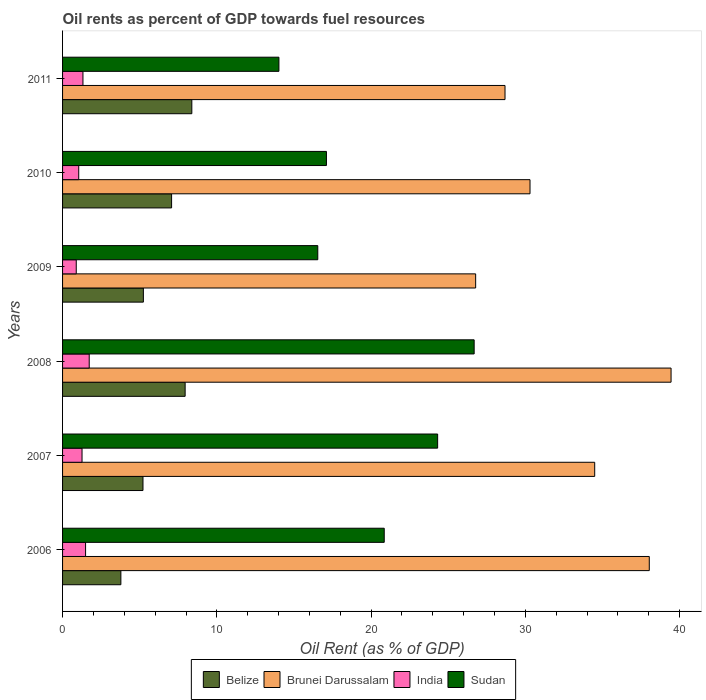How many different coloured bars are there?
Keep it short and to the point. 4. How many groups of bars are there?
Your answer should be very brief. 6. Are the number of bars per tick equal to the number of legend labels?
Offer a very short reply. Yes. How many bars are there on the 3rd tick from the top?
Your answer should be very brief. 4. What is the label of the 1st group of bars from the top?
Give a very brief answer. 2011. What is the oil rent in Brunei Darussalam in 2009?
Your answer should be very brief. 26.77. Across all years, what is the maximum oil rent in Brunei Darussalam?
Offer a terse response. 39.44. Across all years, what is the minimum oil rent in Sudan?
Ensure brevity in your answer.  14.02. What is the total oil rent in Belize in the graph?
Ensure brevity in your answer.  37.62. What is the difference between the oil rent in Sudan in 2008 and that in 2011?
Your answer should be compact. 12.65. What is the difference between the oil rent in India in 2010 and the oil rent in Brunei Darussalam in 2007?
Your response must be concise. -33.44. What is the average oil rent in Sudan per year?
Offer a terse response. 19.92. In the year 2006, what is the difference between the oil rent in Sudan and oil rent in Brunei Darussalam?
Offer a terse response. -17.18. What is the ratio of the oil rent in Sudan in 2006 to that in 2010?
Provide a succinct answer. 1.22. Is the oil rent in Sudan in 2006 less than that in 2010?
Ensure brevity in your answer.  No. What is the difference between the highest and the second highest oil rent in India?
Provide a succinct answer. 0.24. What is the difference between the highest and the lowest oil rent in Belize?
Your answer should be very brief. 4.6. Is the sum of the oil rent in Brunei Darussalam in 2007 and 2008 greater than the maximum oil rent in Belize across all years?
Your answer should be very brief. Yes. What does the 3rd bar from the top in 2009 represents?
Offer a terse response. Brunei Darussalam. What does the 4th bar from the bottom in 2008 represents?
Offer a very short reply. Sudan. How many bars are there?
Keep it short and to the point. 24. How many years are there in the graph?
Provide a short and direct response. 6. What is the difference between two consecutive major ticks on the X-axis?
Provide a succinct answer. 10. Does the graph contain grids?
Your answer should be compact. No. Where does the legend appear in the graph?
Your answer should be very brief. Bottom center. How many legend labels are there?
Your answer should be very brief. 4. How are the legend labels stacked?
Provide a succinct answer. Horizontal. What is the title of the graph?
Your answer should be very brief. Oil rents as percent of GDP towards fuel resources. Does "High income: nonOECD" appear as one of the legend labels in the graph?
Your response must be concise. No. What is the label or title of the X-axis?
Make the answer very short. Oil Rent (as % of GDP). What is the label or title of the Y-axis?
Offer a very short reply. Years. What is the Oil Rent (as % of GDP) in Belize in 2006?
Keep it short and to the point. 3.78. What is the Oil Rent (as % of GDP) of Brunei Darussalam in 2006?
Ensure brevity in your answer.  38.03. What is the Oil Rent (as % of GDP) in India in 2006?
Make the answer very short. 1.49. What is the Oil Rent (as % of GDP) of Sudan in 2006?
Offer a very short reply. 20.85. What is the Oil Rent (as % of GDP) of Belize in 2007?
Your answer should be compact. 5.21. What is the Oil Rent (as % of GDP) of Brunei Darussalam in 2007?
Provide a short and direct response. 34.49. What is the Oil Rent (as % of GDP) of India in 2007?
Keep it short and to the point. 1.26. What is the Oil Rent (as % of GDP) in Sudan in 2007?
Make the answer very short. 24.31. What is the Oil Rent (as % of GDP) in Belize in 2008?
Your answer should be compact. 7.94. What is the Oil Rent (as % of GDP) in Brunei Darussalam in 2008?
Your response must be concise. 39.44. What is the Oil Rent (as % of GDP) in India in 2008?
Your answer should be compact. 1.73. What is the Oil Rent (as % of GDP) of Sudan in 2008?
Keep it short and to the point. 26.68. What is the Oil Rent (as % of GDP) in Belize in 2009?
Provide a short and direct response. 5.24. What is the Oil Rent (as % of GDP) of Brunei Darussalam in 2009?
Provide a short and direct response. 26.77. What is the Oil Rent (as % of GDP) of India in 2009?
Give a very brief answer. 0.89. What is the Oil Rent (as % of GDP) in Sudan in 2009?
Provide a succinct answer. 16.54. What is the Oil Rent (as % of GDP) in Belize in 2010?
Ensure brevity in your answer.  7.07. What is the Oil Rent (as % of GDP) in Brunei Darussalam in 2010?
Keep it short and to the point. 30.3. What is the Oil Rent (as % of GDP) of India in 2010?
Your response must be concise. 1.05. What is the Oil Rent (as % of GDP) of Sudan in 2010?
Make the answer very short. 17.1. What is the Oil Rent (as % of GDP) of Belize in 2011?
Keep it short and to the point. 8.38. What is the Oil Rent (as % of GDP) of Brunei Darussalam in 2011?
Your answer should be compact. 28.68. What is the Oil Rent (as % of GDP) in India in 2011?
Your answer should be compact. 1.32. What is the Oil Rent (as % of GDP) in Sudan in 2011?
Provide a short and direct response. 14.02. Across all years, what is the maximum Oil Rent (as % of GDP) of Belize?
Provide a succinct answer. 8.38. Across all years, what is the maximum Oil Rent (as % of GDP) of Brunei Darussalam?
Your answer should be compact. 39.44. Across all years, what is the maximum Oil Rent (as % of GDP) in India?
Your answer should be compact. 1.73. Across all years, what is the maximum Oil Rent (as % of GDP) of Sudan?
Offer a terse response. 26.68. Across all years, what is the minimum Oil Rent (as % of GDP) of Belize?
Offer a terse response. 3.78. Across all years, what is the minimum Oil Rent (as % of GDP) of Brunei Darussalam?
Make the answer very short. 26.77. Across all years, what is the minimum Oil Rent (as % of GDP) in India?
Provide a succinct answer. 0.89. Across all years, what is the minimum Oil Rent (as % of GDP) in Sudan?
Offer a very short reply. 14.02. What is the total Oil Rent (as % of GDP) in Belize in the graph?
Ensure brevity in your answer.  37.62. What is the total Oil Rent (as % of GDP) in Brunei Darussalam in the graph?
Provide a succinct answer. 197.71. What is the total Oil Rent (as % of GDP) of India in the graph?
Offer a very short reply. 7.74. What is the total Oil Rent (as % of GDP) of Sudan in the graph?
Offer a very short reply. 119.51. What is the difference between the Oil Rent (as % of GDP) of Belize in 2006 and that in 2007?
Give a very brief answer. -1.43. What is the difference between the Oil Rent (as % of GDP) in Brunei Darussalam in 2006 and that in 2007?
Your answer should be compact. 3.54. What is the difference between the Oil Rent (as % of GDP) in India in 2006 and that in 2007?
Give a very brief answer. 0.23. What is the difference between the Oil Rent (as % of GDP) of Sudan in 2006 and that in 2007?
Ensure brevity in your answer.  -3.46. What is the difference between the Oil Rent (as % of GDP) in Belize in 2006 and that in 2008?
Provide a short and direct response. -4.17. What is the difference between the Oil Rent (as % of GDP) of Brunei Darussalam in 2006 and that in 2008?
Your answer should be compact. -1.41. What is the difference between the Oil Rent (as % of GDP) of India in 2006 and that in 2008?
Offer a terse response. -0.24. What is the difference between the Oil Rent (as % of GDP) of Sudan in 2006 and that in 2008?
Offer a very short reply. -5.83. What is the difference between the Oil Rent (as % of GDP) in Belize in 2006 and that in 2009?
Keep it short and to the point. -1.46. What is the difference between the Oil Rent (as % of GDP) of Brunei Darussalam in 2006 and that in 2009?
Your response must be concise. 11.25. What is the difference between the Oil Rent (as % of GDP) in India in 2006 and that in 2009?
Provide a succinct answer. 0.6. What is the difference between the Oil Rent (as % of GDP) in Sudan in 2006 and that in 2009?
Provide a succinct answer. 4.31. What is the difference between the Oil Rent (as % of GDP) in Belize in 2006 and that in 2010?
Keep it short and to the point. -3.29. What is the difference between the Oil Rent (as % of GDP) of Brunei Darussalam in 2006 and that in 2010?
Give a very brief answer. 7.73. What is the difference between the Oil Rent (as % of GDP) in India in 2006 and that in 2010?
Offer a very short reply. 0.44. What is the difference between the Oil Rent (as % of GDP) of Sudan in 2006 and that in 2010?
Make the answer very short. 3.75. What is the difference between the Oil Rent (as % of GDP) of Belize in 2006 and that in 2011?
Keep it short and to the point. -4.6. What is the difference between the Oil Rent (as % of GDP) in Brunei Darussalam in 2006 and that in 2011?
Keep it short and to the point. 9.35. What is the difference between the Oil Rent (as % of GDP) of India in 2006 and that in 2011?
Provide a short and direct response. 0.17. What is the difference between the Oil Rent (as % of GDP) in Sudan in 2006 and that in 2011?
Provide a succinct answer. 6.83. What is the difference between the Oil Rent (as % of GDP) of Belize in 2007 and that in 2008?
Provide a short and direct response. -2.73. What is the difference between the Oil Rent (as % of GDP) of Brunei Darussalam in 2007 and that in 2008?
Offer a very short reply. -4.95. What is the difference between the Oil Rent (as % of GDP) in India in 2007 and that in 2008?
Your response must be concise. -0.47. What is the difference between the Oil Rent (as % of GDP) of Sudan in 2007 and that in 2008?
Your answer should be very brief. -2.37. What is the difference between the Oil Rent (as % of GDP) in Belize in 2007 and that in 2009?
Provide a short and direct response. -0.03. What is the difference between the Oil Rent (as % of GDP) of Brunei Darussalam in 2007 and that in 2009?
Provide a short and direct response. 7.72. What is the difference between the Oil Rent (as % of GDP) of India in 2007 and that in 2009?
Keep it short and to the point. 0.38. What is the difference between the Oil Rent (as % of GDP) in Sudan in 2007 and that in 2009?
Provide a succinct answer. 7.77. What is the difference between the Oil Rent (as % of GDP) of Belize in 2007 and that in 2010?
Your answer should be compact. -1.85. What is the difference between the Oil Rent (as % of GDP) of Brunei Darussalam in 2007 and that in 2010?
Give a very brief answer. 4.19. What is the difference between the Oil Rent (as % of GDP) of India in 2007 and that in 2010?
Your response must be concise. 0.21. What is the difference between the Oil Rent (as % of GDP) of Sudan in 2007 and that in 2010?
Make the answer very short. 7.21. What is the difference between the Oil Rent (as % of GDP) of Belize in 2007 and that in 2011?
Offer a terse response. -3.17. What is the difference between the Oil Rent (as % of GDP) in Brunei Darussalam in 2007 and that in 2011?
Your response must be concise. 5.81. What is the difference between the Oil Rent (as % of GDP) of India in 2007 and that in 2011?
Offer a very short reply. -0.06. What is the difference between the Oil Rent (as % of GDP) in Sudan in 2007 and that in 2011?
Your answer should be very brief. 10.29. What is the difference between the Oil Rent (as % of GDP) in Belize in 2008 and that in 2009?
Ensure brevity in your answer.  2.71. What is the difference between the Oil Rent (as % of GDP) in Brunei Darussalam in 2008 and that in 2009?
Provide a short and direct response. 12.67. What is the difference between the Oil Rent (as % of GDP) of India in 2008 and that in 2009?
Offer a very short reply. 0.84. What is the difference between the Oil Rent (as % of GDP) of Sudan in 2008 and that in 2009?
Your answer should be very brief. 10.14. What is the difference between the Oil Rent (as % of GDP) in Belize in 2008 and that in 2010?
Ensure brevity in your answer.  0.88. What is the difference between the Oil Rent (as % of GDP) of Brunei Darussalam in 2008 and that in 2010?
Provide a succinct answer. 9.14. What is the difference between the Oil Rent (as % of GDP) in India in 2008 and that in 2010?
Keep it short and to the point. 0.68. What is the difference between the Oil Rent (as % of GDP) in Sudan in 2008 and that in 2010?
Provide a succinct answer. 9.57. What is the difference between the Oil Rent (as % of GDP) of Belize in 2008 and that in 2011?
Ensure brevity in your answer.  -0.43. What is the difference between the Oil Rent (as % of GDP) of Brunei Darussalam in 2008 and that in 2011?
Offer a very short reply. 10.76. What is the difference between the Oil Rent (as % of GDP) in India in 2008 and that in 2011?
Offer a terse response. 0.41. What is the difference between the Oil Rent (as % of GDP) of Sudan in 2008 and that in 2011?
Give a very brief answer. 12.65. What is the difference between the Oil Rent (as % of GDP) in Belize in 2009 and that in 2010?
Your response must be concise. -1.83. What is the difference between the Oil Rent (as % of GDP) in Brunei Darussalam in 2009 and that in 2010?
Your answer should be compact. -3.52. What is the difference between the Oil Rent (as % of GDP) in India in 2009 and that in 2010?
Offer a terse response. -0.16. What is the difference between the Oil Rent (as % of GDP) in Sudan in 2009 and that in 2010?
Give a very brief answer. -0.56. What is the difference between the Oil Rent (as % of GDP) of Belize in 2009 and that in 2011?
Your response must be concise. -3.14. What is the difference between the Oil Rent (as % of GDP) of Brunei Darussalam in 2009 and that in 2011?
Provide a short and direct response. -1.9. What is the difference between the Oil Rent (as % of GDP) of India in 2009 and that in 2011?
Ensure brevity in your answer.  -0.44. What is the difference between the Oil Rent (as % of GDP) in Sudan in 2009 and that in 2011?
Keep it short and to the point. 2.52. What is the difference between the Oil Rent (as % of GDP) in Belize in 2010 and that in 2011?
Offer a terse response. -1.31. What is the difference between the Oil Rent (as % of GDP) in Brunei Darussalam in 2010 and that in 2011?
Keep it short and to the point. 1.62. What is the difference between the Oil Rent (as % of GDP) of India in 2010 and that in 2011?
Make the answer very short. -0.27. What is the difference between the Oil Rent (as % of GDP) of Sudan in 2010 and that in 2011?
Your answer should be very brief. 3.08. What is the difference between the Oil Rent (as % of GDP) of Belize in 2006 and the Oil Rent (as % of GDP) of Brunei Darussalam in 2007?
Your response must be concise. -30.71. What is the difference between the Oil Rent (as % of GDP) in Belize in 2006 and the Oil Rent (as % of GDP) in India in 2007?
Your answer should be very brief. 2.52. What is the difference between the Oil Rent (as % of GDP) in Belize in 2006 and the Oil Rent (as % of GDP) in Sudan in 2007?
Your answer should be compact. -20.53. What is the difference between the Oil Rent (as % of GDP) of Brunei Darussalam in 2006 and the Oil Rent (as % of GDP) of India in 2007?
Make the answer very short. 36.77. What is the difference between the Oil Rent (as % of GDP) in Brunei Darussalam in 2006 and the Oil Rent (as % of GDP) in Sudan in 2007?
Your answer should be compact. 13.72. What is the difference between the Oil Rent (as % of GDP) of India in 2006 and the Oil Rent (as % of GDP) of Sudan in 2007?
Your answer should be compact. -22.82. What is the difference between the Oil Rent (as % of GDP) of Belize in 2006 and the Oil Rent (as % of GDP) of Brunei Darussalam in 2008?
Give a very brief answer. -35.66. What is the difference between the Oil Rent (as % of GDP) of Belize in 2006 and the Oil Rent (as % of GDP) of India in 2008?
Provide a succinct answer. 2.05. What is the difference between the Oil Rent (as % of GDP) of Belize in 2006 and the Oil Rent (as % of GDP) of Sudan in 2008?
Ensure brevity in your answer.  -22.9. What is the difference between the Oil Rent (as % of GDP) of Brunei Darussalam in 2006 and the Oil Rent (as % of GDP) of India in 2008?
Give a very brief answer. 36.3. What is the difference between the Oil Rent (as % of GDP) of Brunei Darussalam in 2006 and the Oil Rent (as % of GDP) of Sudan in 2008?
Your answer should be compact. 11.35. What is the difference between the Oil Rent (as % of GDP) of India in 2006 and the Oil Rent (as % of GDP) of Sudan in 2008?
Keep it short and to the point. -25.19. What is the difference between the Oil Rent (as % of GDP) of Belize in 2006 and the Oil Rent (as % of GDP) of Brunei Darussalam in 2009?
Offer a terse response. -23. What is the difference between the Oil Rent (as % of GDP) of Belize in 2006 and the Oil Rent (as % of GDP) of India in 2009?
Make the answer very short. 2.89. What is the difference between the Oil Rent (as % of GDP) of Belize in 2006 and the Oil Rent (as % of GDP) of Sudan in 2009?
Give a very brief answer. -12.76. What is the difference between the Oil Rent (as % of GDP) of Brunei Darussalam in 2006 and the Oil Rent (as % of GDP) of India in 2009?
Keep it short and to the point. 37.14. What is the difference between the Oil Rent (as % of GDP) of Brunei Darussalam in 2006 and the Oil Rent (as % of GDP) of Sudan in 2009?
Offer a terse response. 21.49. What is the difference between the Oil Rent (as % of GDP) of India in 2006 and the Oil Rent (as % of GDP) of Sudan in 2009?
Give a very brief answer. -15.05. What is the difference between the Oil Rent (as % of GDP) of Belize in 2006 and the Oil Rent (as % of GDP) of Brunei Darussalam in 2010?
Make the answer very short. -26.52. What is the difference between the Oil Rent (as % of GDP) in Belize in 2006 and the Oil Rent (as % of GDP) in India in 2010?
Your answer should be compact. 2.73. What is the difference between the Oil Rent (as % of GDP) in Belize in 2006 and the Oil Rent (as % of GDP) in Sudan in 2010?
Make the answer very short. -13.32. What is the difference between the Oil Rent (as % of GDP) in Brunei Darussalam in 2006 and the Oil Rent (as % of GDP) in India in 2010?
Make the answer very short. 36.98. What is the difference between the Oil Rent (as % of GDP) in Brunei Darussalam in 2006 and the Oil Rent (as % of GDP) in Sudan in 2010?
Offer a terse response. 20.93. What is the difference between the Oil Rent (as % of GDP) of India in 2006 and the Oil Rent (as % of GDP) of Sudan in 2010?
Offer a very short reply. -15.61. What is the difference between the Oil Rent (as % of GDP) in Belize in 2006 and the Oil Rent (as % of GDP) in Brunei Darussalam in 2011?
Your answer should be compact. -24.9. What is the difference between the Oil Rent (as % of GDP) of Belize in 2006 and the Oil Rent (as % of GDP) of India in 2011?
Provide a succinct answer. 2.46. What is the difference between the Oil Rent (as % of GDP) of Belize in 2006 and the Oil Rent (as % of GDP) of Sudan in 2011?
Ensure brevity in your answer.  -10.24. What is the difference between the Oil Rent (as % of GDP) in Brunei Darussalam in 2006 and the Oil Rent (as % of GDP) in India in 2011?
Your response must be concise. 36.71. What is the difference between the Oil Rent (as % of GDP) in Brunei Darussalam in 2006 and the Oil Rent (as % of GDP) in Sudan in 2011?
Make the answer very short. 24.01. What is the difference between the Oil Rent (as % of GDP) of India in 2006 and the Oil Rent (as % of GDP) of Sudan in 2011?
Provide a short and direct response. -12.53. What is the difference between the Oil Rent (as % of GDP) of Belize in 2007 and the Oil Rent (as % of GDP) of Brunei Darussalam in 2008?
Keep it short and to the point. -34.23. What is the difference between the Oil Rent (as % of GDP) of Belize in 2007 and the Oil Rent (as % of GDP) of India in 2008?
Your answer should be compact. 3.48. What is the difference between the Oil Rent (as % of GDP) in Belize in 2007 and the Oil Rent (as % of GDP) in Sudan in 2008?
Provide a succinct answer. -21.47. What is the difference between the Oil Rent (as % of GDP) in Brunei Darussalam in 2007 and the Oil Rent (as % of GDP) in India in 2008?
Give a very brief answer. 32.76. What is the difference between the Oil Rent (as % of GDP) in Brunei Darussalam in 2007 and the Oil Rent (as % of GDP) in Sudan in 2008?
Provide a short and direct response. 7.81. What is the difference between the Oil Rent (as % of GDP) of India in 2007 and the Oil Rent (as % of GDP) of Sudan in 2008?
Offer a very short reply. -25.42. What is the difference between the Oil Rent (as % of GDP) in Belize in 2007 and the Oil Rent (as % of GDP) in Brunei Darussalam in 2009?
Provide a short and direct response. -21.56. What is the difference between the Oil Rent (as % of GDP) of Belize in 2007 and the Oil Rent (as % of GDP) of India in 2009?
Give a very brief answer. 4.33. What is the difference between the Oil Rent (as % of GDP) in Belize in 2007 and the Oil Rent (as % of GDP) in Sudan in 2009?
Ensure brevity in your answer.  -11.33. What is the difference between the Oil Rent (as % of GDP) of Brunei Darussalam in 2007 and the Oil Rent (as % of GDP) of India in 2009?
Your response must be concise. 33.6. What is the difference between the Oil Rent (as % of GDP) in Brunei Darussalam in 2007 and the Oil Rent (as % of GDP) in Sudan in 2009?
Keep it short and to the point. 17.95. What is the difference between the Oil Rent (as % of GDP) in India in 2007 and the Oil Rent (as % of GDP) in Sudan in 2009?
Keep it short and to the point. -15.28. What is the difference between the Oil Rent (as % of GDP) of Belize in 2007 and the Oil Rent (as % of GDP) of Brunei Darussalam in 2010?
Your answer should be compact. -25.09. What is the difference between the Oil Rent (as % of GDP) of Belize in 2007 and the Oil Rent (as % of GDP) of India in 2010?
Give a very brief answer. 4.16. What is the difference between the Oil Rent (as % of GDP) of Belize in 2007 and the Oil Rent (as % of GDP) of Sudan in 2010?
Your answer should be compact. -11.89. What is the difference between the Oil Rent (as % of GDP) in Brunei Darussalam in 2007 and the Oil Rent (as % of GDP) in India in 2010?
Give a very brief answer. 33.44. What is the difference between the Oil Rent (as % of GDP) in Brunei Darussalam in 2007 and the Oil Rent (as % of GDP) in Sudan in 2010?
Give a very brief answer. 17.39. What is the difference between the Oil Rent (as % of GDP) of India in 2007 and the Oil Rent (as % of GDP) of Sudan in 2010?
Give a very brief answer. -15.84. What is the difference between the Oil Rent (as % of GDP) of Belize in 2007 and the Oil Rent (as % of GDP) of Brunei Darussalam in 2011?
Provide a short and direct response. -23.47. What is the difference between the Oil Rent (as % of GDP) in Belize in 2007 and the Oil Rent (as % of GDP) in India in 2011?
Offer a terse response. 3.89. What is the difference between the Oil Rent (as % of GDP) in Belize in 2007 and the Oil Rent (as % of GDP) in Sudan in 2011?
Ensure brevity in your answer.  -8.81. What is the difference between the Oil Rent (as % of GDP) in Brunei Darussalam in 2007 and the Oil Rent (as % of GDP) in India in 2011?
Provide a succinct answer. 33.17. What is the difference between the Oil Rent (as % of GDP) in Brunei Darussalam in 2007 and the Oil Rent (as % of GDP) in Sudan in 2011?
Give a very brief answer. 20.47. What is the difference between the Oil Rent (as % of GDP) in India in 2007 and the Oil Rent (as % of GDP) in Sudan in 2011?
Give a very brief answer. -12.76. What is the difference between the Oil Rent (as % of GDP) in Belize in 2008 and the Oil Rent (as % of GDP) in Brunei Darussalam in 2009?
Ensure brevity in your answer.  -18.83. What is the difference between the Oil Rent (as % of GDP) of Belize in 2008 and the Oil Rent (as % of GDP) of India in 2009?
Your answer should be compact. 7.06. What is the difference between the Oil Rent (as % of GDP) of Belize in 2008 and the Oil Rent (as % of GDP) of Sudan in 2009?
Keep it short and to the point. -8.6. What is the difference between the Oil Rent (as % of GDP) in Brunei Darussalam in 2008 and the Oil Rent (as % of GDP) in India in 2009?
Offer a very short reply. 38.55. What is the difference between the Oil Rent (as % of GDP) of Brunei Darussalam in 2008 and the Oil Rent (as % of GDP) of Sudan in 2009?
Provide a short and direct response. 22.9. What is the difference between the Oil Rent (as % of GDP) in India in 2008 and the Oil Rent (as % of GDP) in Sudan in 2009?
Your answer should be very brief. -14.81. What is the difference between the Oil Rent (as % of GDP) of Belize in 2008 and the Oil Rent (as % of GDP) of Brunei Darussalam in 2010?
Your answer should be compact. -22.35. What is the difference between the Oil Rent (as % of GDP) in Belize in 2008 and the Oil Rent (as % of GDP) in India in 2010?
Offer a terse response. 6.9. What is the difference between the Oil Rent (as % of GDP) of Belize in 2008 and the Oil Rent (as % of GDP) of Sudan in 2010?
Offer a very short reply. -9.16. What is the difference between the Oil Rent (as % of GDP) of Brunei Darussalam in 2008 and the Oil Rent (as % of GDP) of India in 2010?
Your answer should be very brief. 38.39. What is the difference between the Oil Rent (as % of GDP) in Brunei Darussalam in 2008 and the Oil Rent (as % of GDP) in Sudan in 2010?
Provide a succinct answer. 22.34. What is the difference between the Oil Rent (as % of GDP) in India in 2008 and the Oil Rent (as % of GDP) in Sudan in 2010?
Ensure brevity in your answer.  -15.38. What is the difference between the Oil Rent (as % of GDP) of Belize in 2008 and the Oil Rent (as % of GDP) of Brunei Darussalam in 2011?
Provide a succinct answer. -20.73. What is the difference between the Oil Rent (as % of GDP) in Belize in 2008 and the Oil Rent (as % of GDP) in India in 2011?
Provide a succinct answer. 6.62. What is the difference between the Oil Rent (as % of GDP) of Belize in 2008 and the Oil Rent (as % of GDP) of Sudan in 2011?
Your answer should be compact. -6.08. What is the difference between the Oil Rent (as % of GDP) of Brunei Darussalam in 2008 and the Oil Rent (as % of GDP) of India in 2011?
Your response must be concise. 38.12. What is the difference between the Oil Rent (as % of GDP) of Brunei Darussalam in 2008 and the Oil Rent (as % of GDP) of Sudan in 2011?
Provide a succinct answer. 25.42. What is the difference between the Oil Rent (as % of GDP) of India in 2008 and the Oil Rent (as % of GDP) of Sudan in 2011?
Ensure brevity in your answer.  -12.3. What is the difference between the Oil Rent (as % of GDP) of Belize in 2009 and the Oil Rent (as % of GDP) of Brunei Darussalam in 2010?
Your answer should be very brief. -25.06. What is the difference between the Oil Rent (as % of GDP) of Belize in 2009 and the Oil Rent (as % of GDP) of India in 2010?
Make the answer very short. 4.19. What is the difference between the Oil Rent (as % of GDP) in Belize in 2009 and the Oil Rent (as % of GDP) in Sudan in 2010?
Give a very brief answer. -11.87. What is the difference between the Oil Rent (as % of GDP) in Brunei Darussalam in 2009 and the Oil Rent (as % of GDP) in India in 2010?
Give a very brief answer. 25.73. What is the difference between the Oil Rent (as % of GDP) of Brunei Darussalam in 2009 and the Oil Rent (as % of GDP) of Sudan in 2010?
Offer a terse response. 9.67. What is the difference between the Oil Rent (as % of GDP) of India in 2009 and the Oil Rent (as % of GDP) of Sudan in 2010?
Ensure brevity in your answer.  -16.22. What is the difference between the Oil Rent (as % of GDP) in Belize in 2009 and the Oil Rent (as % of GDP) in Brunei Darussalam in 2011?
Keep it short and to the point. -23.44. What is the difference between the Oil Rent (as % of GDP) of Belize in 2009 and the Oil Rent (as % of GDP) of India in 2011?
Offer a terse response. 3.92. What is the difference between the Oil Rent (as % of GDP) in Belize in 2009 and the Oil Rent (as % of GDP) in Sudan in 2011?
Offer a very short reply. -8.79. What is the difference between the Oil Rent (as % of GDP) in Brunei Darussalam in 2009 and the Oil Rent (as % of GDP) in India in 2011?
Provide a short and direct response. 25.45. What is the difference between the Oil Rent (as % of GDP) of Brunei Darussalam in 2009 and the Oil Rent (as % of GDP) of Sudan in 2011?
Offer a terse response. 12.75. What is the difference between the Oil Rent (as % of GDP) of India in 2009 and the Oil Rent (as % of GDP) of Sudan in 2011?
Provide a succinct answer. -13.14. What is the difference between the Oil Rent (as % of GDP) in Belize in 2010 and the Oil Rent (as % of GDP) in Brunei Darussalam in 2011?
Offer a terse response. -21.61. What is the difference between the Oil Rent (as % of GDP) in Belize in 2010 and the Oil Rent (as % of GDP) in India in 2011?
Provide a succinct answer. 5.74. What is the difference between the Oil Rent (as % of GDP) of Belize in 2010 and the Oil Rent (as % of GDP) of Sudan in 2011?
Your response must be concise. -6.96. What is the difference between the Oil Rent (as % of GDP) in Brunei Darussalam in 2010 and the Oil Rent (as % of GDP) in India in 2011?
Your answer should be very brief. 28.98. What is the difference between the Oil Rent (as % of GDP) in Brunei Darussalam in 2010 and the Oil Rent (as % of GDP) in Sudan in 2011?
Your answer should be compact. 16.27. What is the difference between the Oil Rent (as % of GDP) of India in 2010 and the Oil Rent (as % of GDP) of Sudan in 2011?
Your response must be concise. -12.98. What is the average Oil Rent (as % of GDP) of Belize per year?
Your answer should be very brief. 6.27. What is the average Oil Rent (as % of GDP) in Brunei Darussalam per year?
Give a very brief answer. 32.95. What is the average Oil Rent (as % of GDP) in India per year?
Give a very brief answer. 1.29. What is the average Oil Rent (as % of GDP) of Sudan per year?
Your answer should be very brief. 19.92. In the year 2006, what is the difference between the Oil Rent (as % of GDP) in Belize and Oil Rent (as % of GDP) in Brunei Darussalam?
Offer a very short reply. -34.25. In the year 2006, what is the difference between the Oil Rent (as % of GDP) of Belize and Oil Rent (as % of GDP) of India?
Keep it short and to the point. 2.29. In the year 2006, what is the difference between the Oil Rent (as % of GDP) in Belize and Oil Rent (as % of GDP) in Sudan?
Give a very brief answer. -17.07. In the year 2006, what is the difference between the Oil Rent (as % of GDP) of Brunei Darussalam and Oil Rent (as % of GDP) of India?
Ensure brevity in your answer.  36.54. In the year 2006, what is the difference between the Oil Rent (as % of GDP) of Brunei Darussalam and Oil Rent (as % of GDP) of Sudan?
Provide a succinct answer. 17.18. In the year 2006, what is the difference between the Oil Rent (as % of GDP) in India and Oil Rent (as % of GDP) in Sudan?
Your answer should be very brief. -19.36. In the year 2007, what is the difference between the Oil Rent (as % of GDP) in Belize and Oil Rent (as % of GDP) in Brunei Darussalam?
Your response must be concise. -29.28. In the year 2007, what is the difference between the Oil Rent (as % of GDP) of Belize and Oil Rent (as % of GDP) of India?
Your answer should be very brief. 3.95. In the year 2007, what is the difference between the Oil Rent (as % of GDP) in Belize and Oil Rent (as % of GDP) in Sudan?
Ensure brevity in your answer.  -19.1. In the year 2007, what is the difference between the Oil Rent (as % of GDP) in Brunei Darussalam and Oil Rent (as % of GDP) in India?
Ensure brevity in your answer.  33.23. In the year 2007, what is the difference between the Oil Rent (as % of GDP) of Brunei Darussalam and Oil Rent (as % of GDP) of Sudan?
Give a very brief answer. 10.18. In the year 2007, what is the difference between the Oil Rent (as % of GDP) in India and Oil Rent (as % of GDP) in Sudan?
Provide a succinct answer. -23.05. In the year 2008, what is the difference between the Oil Rent (as % of GDP) of Belize and Oil Rent (as % of GDP) of Brunei Darussalam?
Make the answer very short. -31.5. In the year 2008, what is the difference between the Oil Rent (as % of GDP) in Belize and Oil Rent (as % of GDP) in India?
Your answer should be very brief. 6.22. In the year 2008, what is the difference between the Oil Rent (as % of GDP) of Belize and Oil Rent (as % of GDP) of Sudan?
Your answer should be compact. -18.73. In the year 2008, what is the difference between the Oil Rent (as % of GDP) in Brunei Darussalam and Oil Rent (as % of GDP) in India?
Make the answer very short. 37.71. In the year 2008, what is the difference between the Oil Rent (as % of GDP) in Brunei Darussalam and Oil Rent (as % of GDP) in Sudan?
Provide a short and direct response. 12.76. In the year 2008, what is the difference between the Oil Rent (as % of GDP) of India and Oil Rent (as % of GDP) of Sudan?
Provide a short and direct response. -24.95. In the year 2009, what is the difference between the Oil Rent (as % of GDP) of Belize and Oil Rent (as % of GDP) of Brunei Darussalam?
Offer a very short reply. -21.54. In the year 2009, what is the difference between the Oil Rent (as % of GDP) of Belize and Oil Rent (as % of GDP) of India?
Your answer should be very brief. 4.35. In the year 2009, what is the difference between the Oil Rent (as % of GDP) in Belize and Oil Rent (as % of GDP) in Sudan?
Make the answer very short. -11.3. In the year 2009, what is the difference between the Oil Rent (as % of GDP) of Brunei Darussalam and Oil Rent (as % of GDP) of India?
Your answer should be compact. 25.89. In the year 2009, what is the difference between the Oil Rent (as % of GDP) of Brunei Darussalam and Oil Rent (as % of GDP) of Sudan?
Provide a short and direct response. 10.23. In the year 2009, what is the difference between the Oil Rent (as % of GDP) of India and Oil Rent (as % of GDP) of Sudan?
Your response must be concise. -15.66. In the year 2010, what is the difference between the Oil Rent (as % of GDP) in Belize and Oil Rent (as % of GDP) in Brunei Darussalam?
Ensure brevity in your answer.  -23.23. In the year 2010, what is the difference between the Oil Rent (as % of GDP) in Belize and Oil Rent (as % of GDP) in India?
Ensure brevity in your answer.  6.02. In the year 2010, what is the difference between the Oil Rent (as % of GDP) of Belize and Oil Rent (as % of GDP) of Sudan?
Provide a succinct answer. -10.04. In the year 2010, what is the difference between the Oil Rent (as % of GDP) in Brunei Darussalam and Oil Rent (as % of GDP) in India?
Make the answer very short. 29.25. In the year 2010, what is the difference between the Oil Rent (as % of GDP) of Brunei Darussalam and Oil Rent (as % of GDP) of Sudan?
Your answer should be compact. 13.2. In the year 2010, what is the difference between the Oil Rent (as % of GDP) of India and Oil Rent (as % of GDP) of Sudan?
Your answer should be very brief. -16.05. In the year 2011, what is the difference between the Oil Rent (as % of GDP) in Belize and Oil Rent (as % of GDP) in Brunei Darussalam?
Your answer should be very brief. -20.3. In the year 2011, what is the difference between the Oil Rent (as % of GDP) of Belize and Oil Rent (as % of GDP) of India?
Your answer should be compact. 7.06. In the year 2011, what is the difference between the Oil Rent (as % of GDP) of Belize and Oil Rent (as % of GDP) of Sudan?
Keep it short and to the point. -5.65. In the year 2011, what is the difference between the Oil Rent (as % of GDP) of Brunei Darussalam and Oil Rent (as % of GDP) of India?
Make the answer very short. 27.36. In the year 2011, what is the difference between the Oil Rent (as % of GDP) of Brunei Darussalam and Oil Rent (as % of GDP) of Sudan?
Provide a short and direct response. 14.65. In the year 2011, what is the difference between the Oil Rent (as % of GDP) in India and Oil Rent (as % of GDP) in Sudan?
Provide a short and direct response. -12.7. What is the ratio of the Oil Rent (as % of GDP) in Belize in 2006 to that in 2007?
Provide a short and direct response. 0.73. What is the ratio of the Oil Rent (as % of GDP) in Brunei Darussalam in 2006 to that in 2007?
Your response must be concise. 1.1. What is the ratio of the Oil Rent (as % of GDP) of India in 2006 to that in 2007?
Provide a succinct answer. 1.18. What is the ratio of the Oil Rent (as % of GDP) of Sudan in 2006 to that in 2007?
Your response must be concise. 0.86. What is the ratio of the Oil Rent (as % of GDP) in Belize in 2006 to that in 2008?
Offer a very short reply. 0.48. What is the ratio of the Oil Rent (as % of GDP) of Brunei Darussalam in 2006 to that in 2008?
Your answer should be compact. 0.96. What is the ratio of the Oil Rent (as % of GDP) in India in 2006 to that in 2008?
Provide a succinct answer. 0.86. What is the ratio of the Oil Rent (as % of GDP) in Sudan in 2006 to that in 2008?
Provide a short and direct response. 0.78. What is the ratio of the Oil Rent (as % of GDP) of Belize in 2006 to that in 2009?
Offer a very short reply. 0.72. What is the ratio of the Oil Rent (as % of GDP) of Brunei Darussalam in 2006 to that in 2009?
Your answer should be very brief. 1.42. What is the ratio of the Oil Rent (as % of GDP) in India in 2006 to that in 2009?
Keep it short and to the point. 1.68. What is the ratio of the Oil Rent (as % of GDP) in Sudan in 2006 to that in 2009?
Make the answer very short. 1.26. What is the ratio of the Oil Rent (as % of GDP) in Belize in 2006 to that in 2010?
Provide a succinct answer. 0.53. What is the ratio of the Oil Rent (as % of GDP) of Brunei Darussalam in 2006 to that in 2010?
Give a very brief answer. 1.26. What is the ratio of the Oil Rent (as % of GDP) of India in 2006 to that in 2010?
Give a very brief answer. 1.42. What is the ratio of the Oil Rent (as % of GDP) of Sudan in 2006 to that in 2010?
Your answer should be very brief. 1.22. What is the ratio of the Oil Rent (as % of GDP) in Belize in 2006 to that in 2011?
Provide a short and direct response. 0.45. What is the ratio of the Oil Rent (as % of GDP) in Brunei Darussalam in 2006 to that in 2011?
Offer a very short reply. 1.33. What is the ratio of the Oil Rent (as % of GDP) in India in 2006 to that in 2011?
Your answer should be compact. 1.13. What is the ratio of the Oil Rent (as % of GDP) of Sudan in 2006 to that in 2011?
Provide a short and direct response. 1.49. What is the ratio of the Oil Rent (as % of GDP) of Belize in 2007 to that in 2008?
Offer a terse response. 0.66. What is the ratio of the Oil Rent (as % of GDP) in Brunei Darussalam in 2007 to that in 2008?
Your response must be concise. 0.87. What is the ratio of the Oil Rent (as % of GDP) of India in 2007 to that in 2008?
Offer a very short reply. 0.73. What is the ratio of the Oil Rent (as % of GDP) in Sudan in 2007 to that in 2008?
Give a very brief answer. 0.91. What is the ratio of the Oil Rent (as % of GDP) in Belize in 2007 to that in 2009?
Provide a short and direct response. 1. What is the ratio of the Oil Rent (as % of GDP) in Brunei Darussalam in 2007 to that in 2009?
Provide a short and direct response. 1.29. What is the ratio of the Oil Rent (as % of GDP) in India in 2007 to that in 2009?
Provide a succinct answer. 1.42. What is the ratio of the Oil Rent (as % of GDP) of Sudan in 2007 to that in 2009?
Your response must be concise. 1.47. What is the ratio of the Oil Rent (as % of GDP) of Belize in 2007 to that in 2010?
Offer a terse response. 0.74. What is the ratio of the Oil Rent (as % of GDP) in Brunei Darussalam in 2007 to that in 2010?
Provide a succinct answer. 1.14. What is the ratio of the Oil Rent (as % of GDP) in India in 2007 to that in 2010?
Provide a succinct answer. 1.2. What is the ratio of the Oil Rent (as % of GDP) of Sudan in 2007 to that in 2010?
Your response must be concise. 1.42. What is the ratio of the Oil Rent (as % of GDP) in Belize in 2007 to that in 2011?
Make the answer very short. 0.62. What is the ratio of the Oil Rent (as % of GDP) of Brunei Darussalam in 2007 to that in 2011?
Offer a very short reply. 1.2. What is the ratio of the Oil Rent (as % of GDP) in India in 2007 to that in 2011?
Provide a short and direct response. 0.95. What is the ratio of the Oil Rent (as % of GDP) of Sudan in 2007 to that in 2011?
Ensure brevity in your answer.  1.73. What is the ratio of the Oil Rent (as % of GDP) in Belize in 2008 to that in 2009?
Ensure brevity in your answer.  1.52. What is the ratio of the Oil Rent (as % of GDP) in Brunei Darussalam in 2008 to that in 2009?
Your answer should be compact. 1.47. What is the ratio of the Oil Rent (as % of GDP) in India in 2008 to that in 2009?
Provide a short and direct response. 1.95. What is the ratio of the Oil Rent (as % of GDP) of Sudan in 2008 to that in 2009?
Provide a short and direct response. 1.61. What is the ratio of the Oil Rent (as % of GDP) in Belize in 2008 to that in 2010?
Offer a terse response. 1.12. What is the ratio of the Oil Rent (as % of GDP) of Brunei Darussalam in 2008 to that in 2010?
Your answer should be very brief. 1.3. What is the ratio of the Oil Rent (as % of GDP) of India in 2008 to that in 2010?
Make the answer very short. 1.65. What is the ratio of the Oil Rent (as % of GDP) of Sudan in 2008 to that in 2010?
Offer a terse response. 1.56. What is the ratio of the Oil Rent (as % of GDP) of Belize in 2008 to that in 2011?
Ensure brevity in your answer.  0.95. What is the ratio of the Oil Rent (as % of GDP) in Brunei Darussalam in 2008 to that in 2011?
Ensure brevity in your answer.  1.38. What is the ratio of the Oil Rent (as % of GDP) of India in 2008 to that in 2011?
Your answer should be compact. 1.31. What is the ratio of the Oil Rent (as % of GDP) in Sudan in 2008 to that in 2011?
Provide a short and direct response. 1.9. What is the ratio of the Oil Rent (as % of GDP) in Belize in 2009 to that in 2010?
Your response must be concise. 0.74. What is the ratio of the Oil Rent (as % of GDP) in Brunei Darussalam in 2009 to that in 2010?
Offer a very short reply. 0.88. What is the ratio of the Oil Rent (as % of GDP) of India in 2009 to that in 2010?
Keep it short and to the point. 0.85. What is the ratio of the Oil Rent (as % of GDP) of Sudan in 2009 to that in 2010?
Offer a very short reply. 0.97. What is the ratio of the Oil Rent (as % of GDP) in Belize in 2009 to that in 2011?
Your answer should be very brief. 0.63. What is the ratio of the Oil Rent (as % of GDP) in Brunei Darussalam in 2009 to that in 2011?
Give a very brief answer. 0.93. What is the ratio of the Oil Rent (as % of GDP) in India in 2009 to that in 2011?
Offer a terse response. 0.67. What is the ratio of the Oil Rent (as % of GDP) in Sudan in 2009 to that in 2011?
Your answer should be compact. 1.18. What is the ratio of the Oil Rent (as % of GDP) of Belize in 2010 to that in 2011?
Provide a succinct answer. 0.84. What is the ratio of the Oil Rent (as % of GDP) in Brunei Darussalam in 2010 to that in 2011?
Offer a terse response. 1.06. What is the ratio of the Oil Rent (as % of GDP) in India in 2010 to that in 2011?
Your answer should be very brief. 0.79. What is the ratio of the Oil Rent (as % of GDP) in Sudan in 2010 to that in 2011?
Your response must be concise. 1.22. What is the difference between the highest and the second highest Oil Rent (as % of GDP) of Belize?
Your response must be concise. 0.43. What is the difference between the highest and the second highest Oil Rent (as % of GDP) in Brunei Darussalam?
Provide a short and direct response. 1.41. What is the difference between the highest and the second highest Oil Rent (as % of GDP) of India?
Your response must be concise. 0.24. What is the difference between the highest and the second highest Oil Rent (as % of GDP) in Sudan?
Your answer should be compact. 2.37. What is the difference between the highest and the lowest Oil Rent (as % of GDP) of Belize?
Keep it short and to the point. 4.6. What is the difference between the highest and the lowest Oil Rent (as % of GDP) of Brunei Darussalam?
Your answer should be compact. 12.67. What is the difference between the highest and the lowest Oil Rent (as % of GDP) in India?
Provide a succinct answer. 0.84. What is the difference between the highest and the lowest Oil Rent (as % of GDP) of Sudan?
Give a very brief answer. 12.65. 